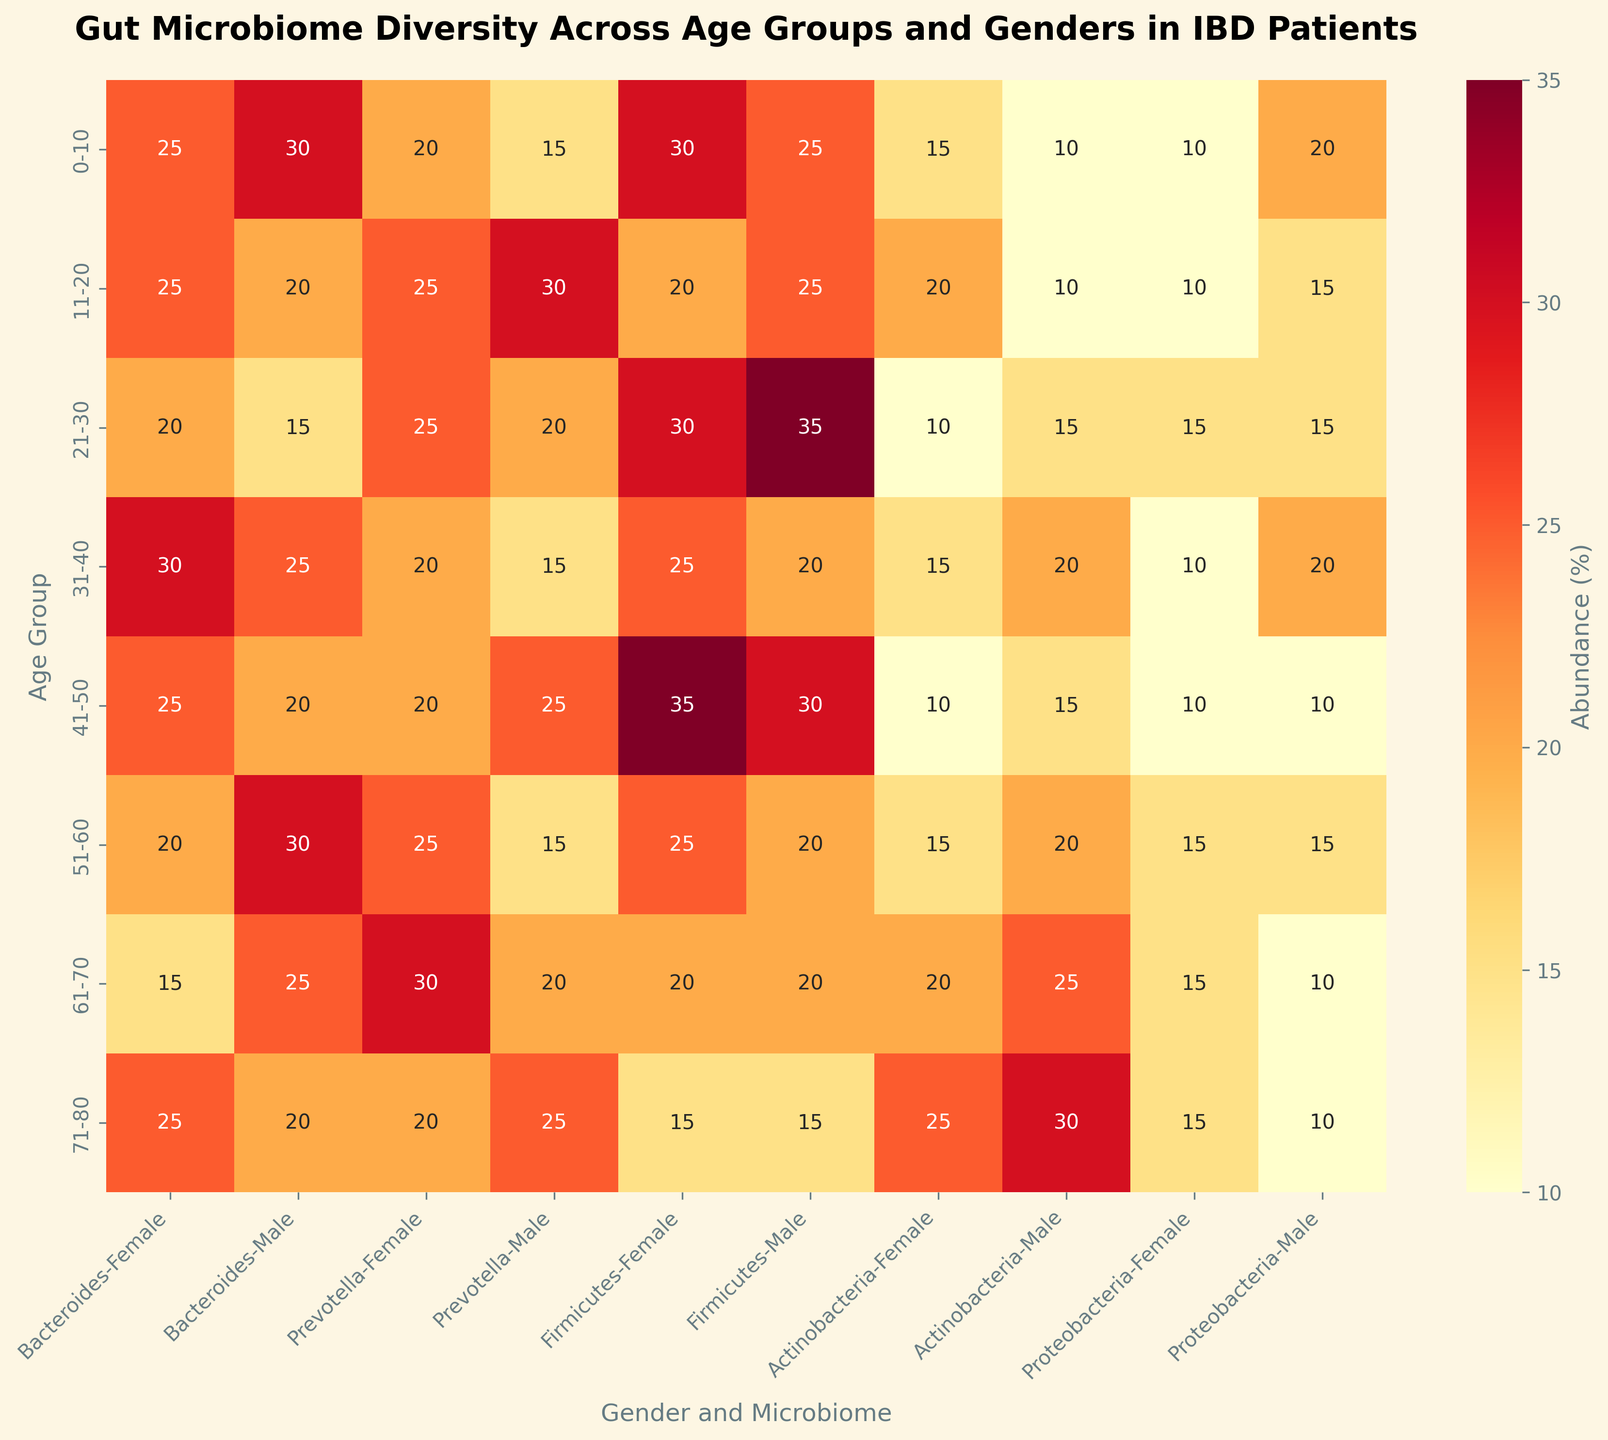What is the title of the heatmap figure? The title is displayed at the top center of the figure.
Answer: Gut Microbiome Diversity Across Age Groups and Genders in IBD Patients Which age group has the highest abundance of Bacteroides among males? Look for the highest value in the Bacteroides category under the male column and compare within age groups.
Answer: 51-60 Between males and females in the 21-30 age group, who has a higher abundance of Prevotella? Check the values for Prevotella in both genders within the 21-30 age group and compare them.
Answer: Female What is the range of values for Actinobacteria across all age groups? Identify the minimum and maximum values for Actinobacteria across all age groups and genders from the heatmap.
Answer: 10 to 30 Compare the abundance of Firmicutes between the 0-10 and 11-20 age groups in males. Which age group has a higher abundance? Locate the Firmicutes values for the two age groups under the male column and compare them.
Answer: 21-30 Which gender in the 61-70 age group has a higher abundance of Proteobacteria, and by how much? Check the values of Proteobacteria for both genders in the 61-70 age group and calculate the difference.
Answer: Female by 5 What is the total abundance of Prevotella in all age groups for females? Sum the values of Prevotella for females in each age group.
Answer: 165 Is the abundance distribution for Bacteroides more similar between genders or age groups? Compare the patterns of Bacteroides values across gender columns and age groups.
Answer: Age groups How does the abundance of Actinobacteria change with age in males? Observe the pattern or trend in the Actinobacteria values across different age groups under the male column.
Answer: Increases with age What is the median value of Proteobacteria for all the data points? Collect all values of Proteobacteria, sort them, and find the middle value.
Answer: 15 